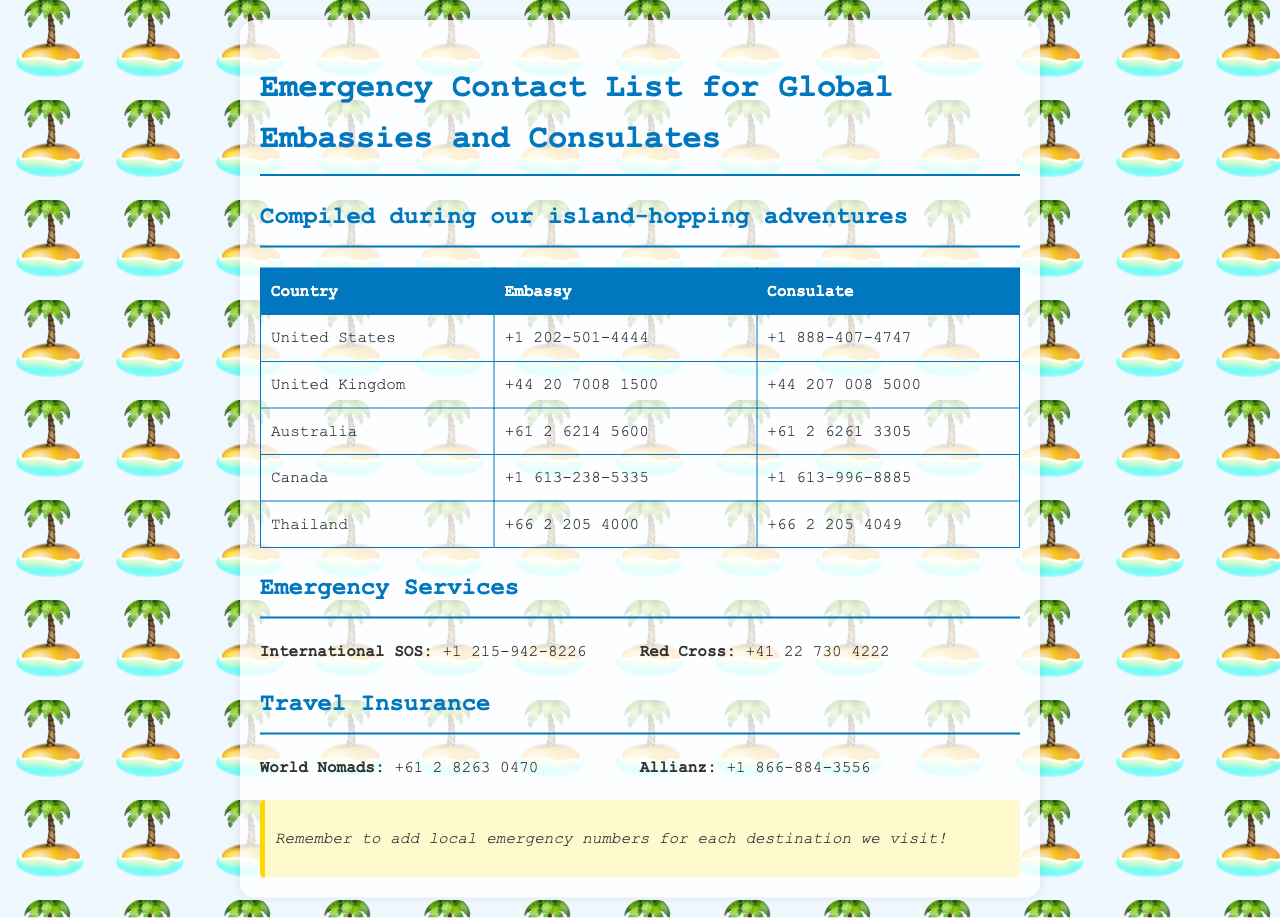What is the embassy contact number for the United States? The embassy number for the United States is listed in the table as +1 202-501-4444.
Answer: +1 202-501-4444 What is the contact number for the Allianz travel insurance? The contact number for Allianz travel insurance is provided in the document as +1 866-884-3556.
Answer: +1 866-884-3556 Which country has a consulate contact number of +61 2 6261 3305? The consulate number +61 2 6261 3305 is associated with Australia, as indicated in the table.
Answer: Australia What is the contact number for the Red Cross? The document states the Red Cross contact number as +41 22 730 4222.
Answer: +41 22 730 4222 Which travel insurance service has a number starting with +61? The document lists World Nomads with the number +61 2 8263 0470, indicating it starts with +61.
Answer: World Nomads How many emergency services are listed in the document? There are two emergency services mentioned in the document: International SOS and Red Cross.
Answer: 2 